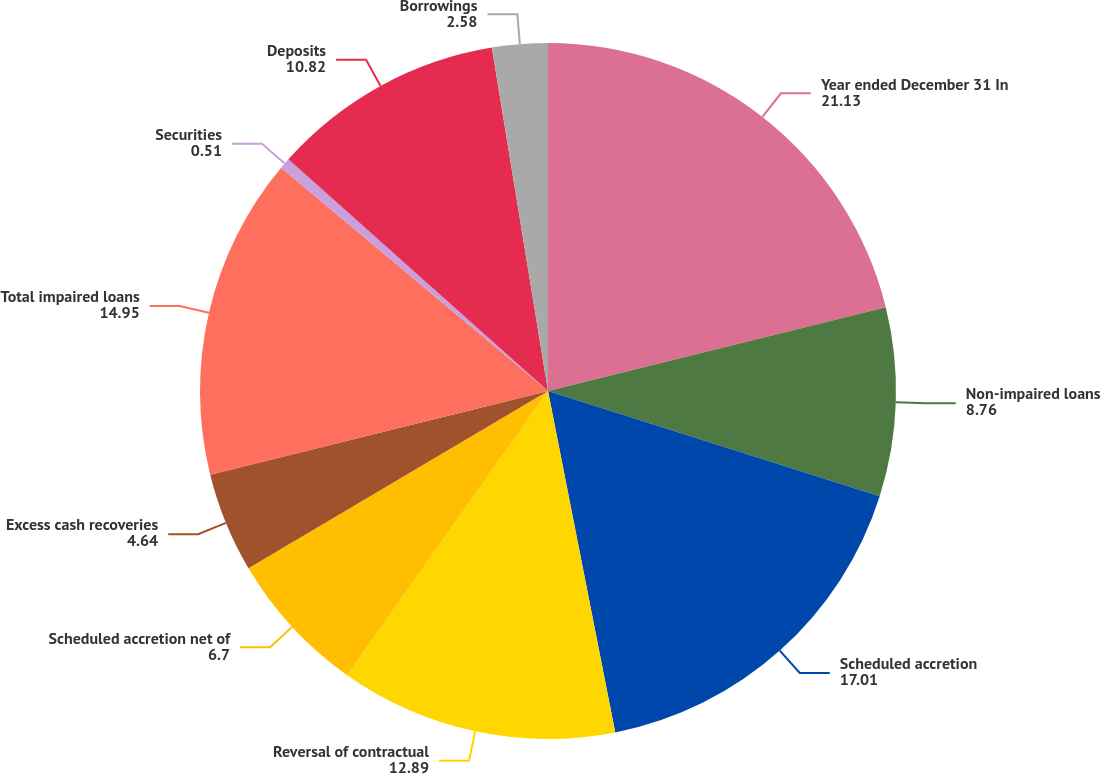Convert chart. <chart><loc_0><loc_0><loc_500><loc_500><pie_chart><fcel>Year ended December 31 In<fcel>Non-impaired loans<fcel>Scheduled accretion<fcel>Reversal of contractual<fcel>Scheduled accretion net of<fcel>Excess cash recoveries<fcel>Total impaired loans<fcel>Securities<fcel>Deposits<fcel>Borrowings<nl><fcel>21.13%<fcel>8.76%<fcel>17.01%<fcel>12.89%<fcel>6.7%<fcel>4.64%<fcel>14.95%<fcel>0.51%<fcel>10.82%<fcel>2.58%<nl></chart> 